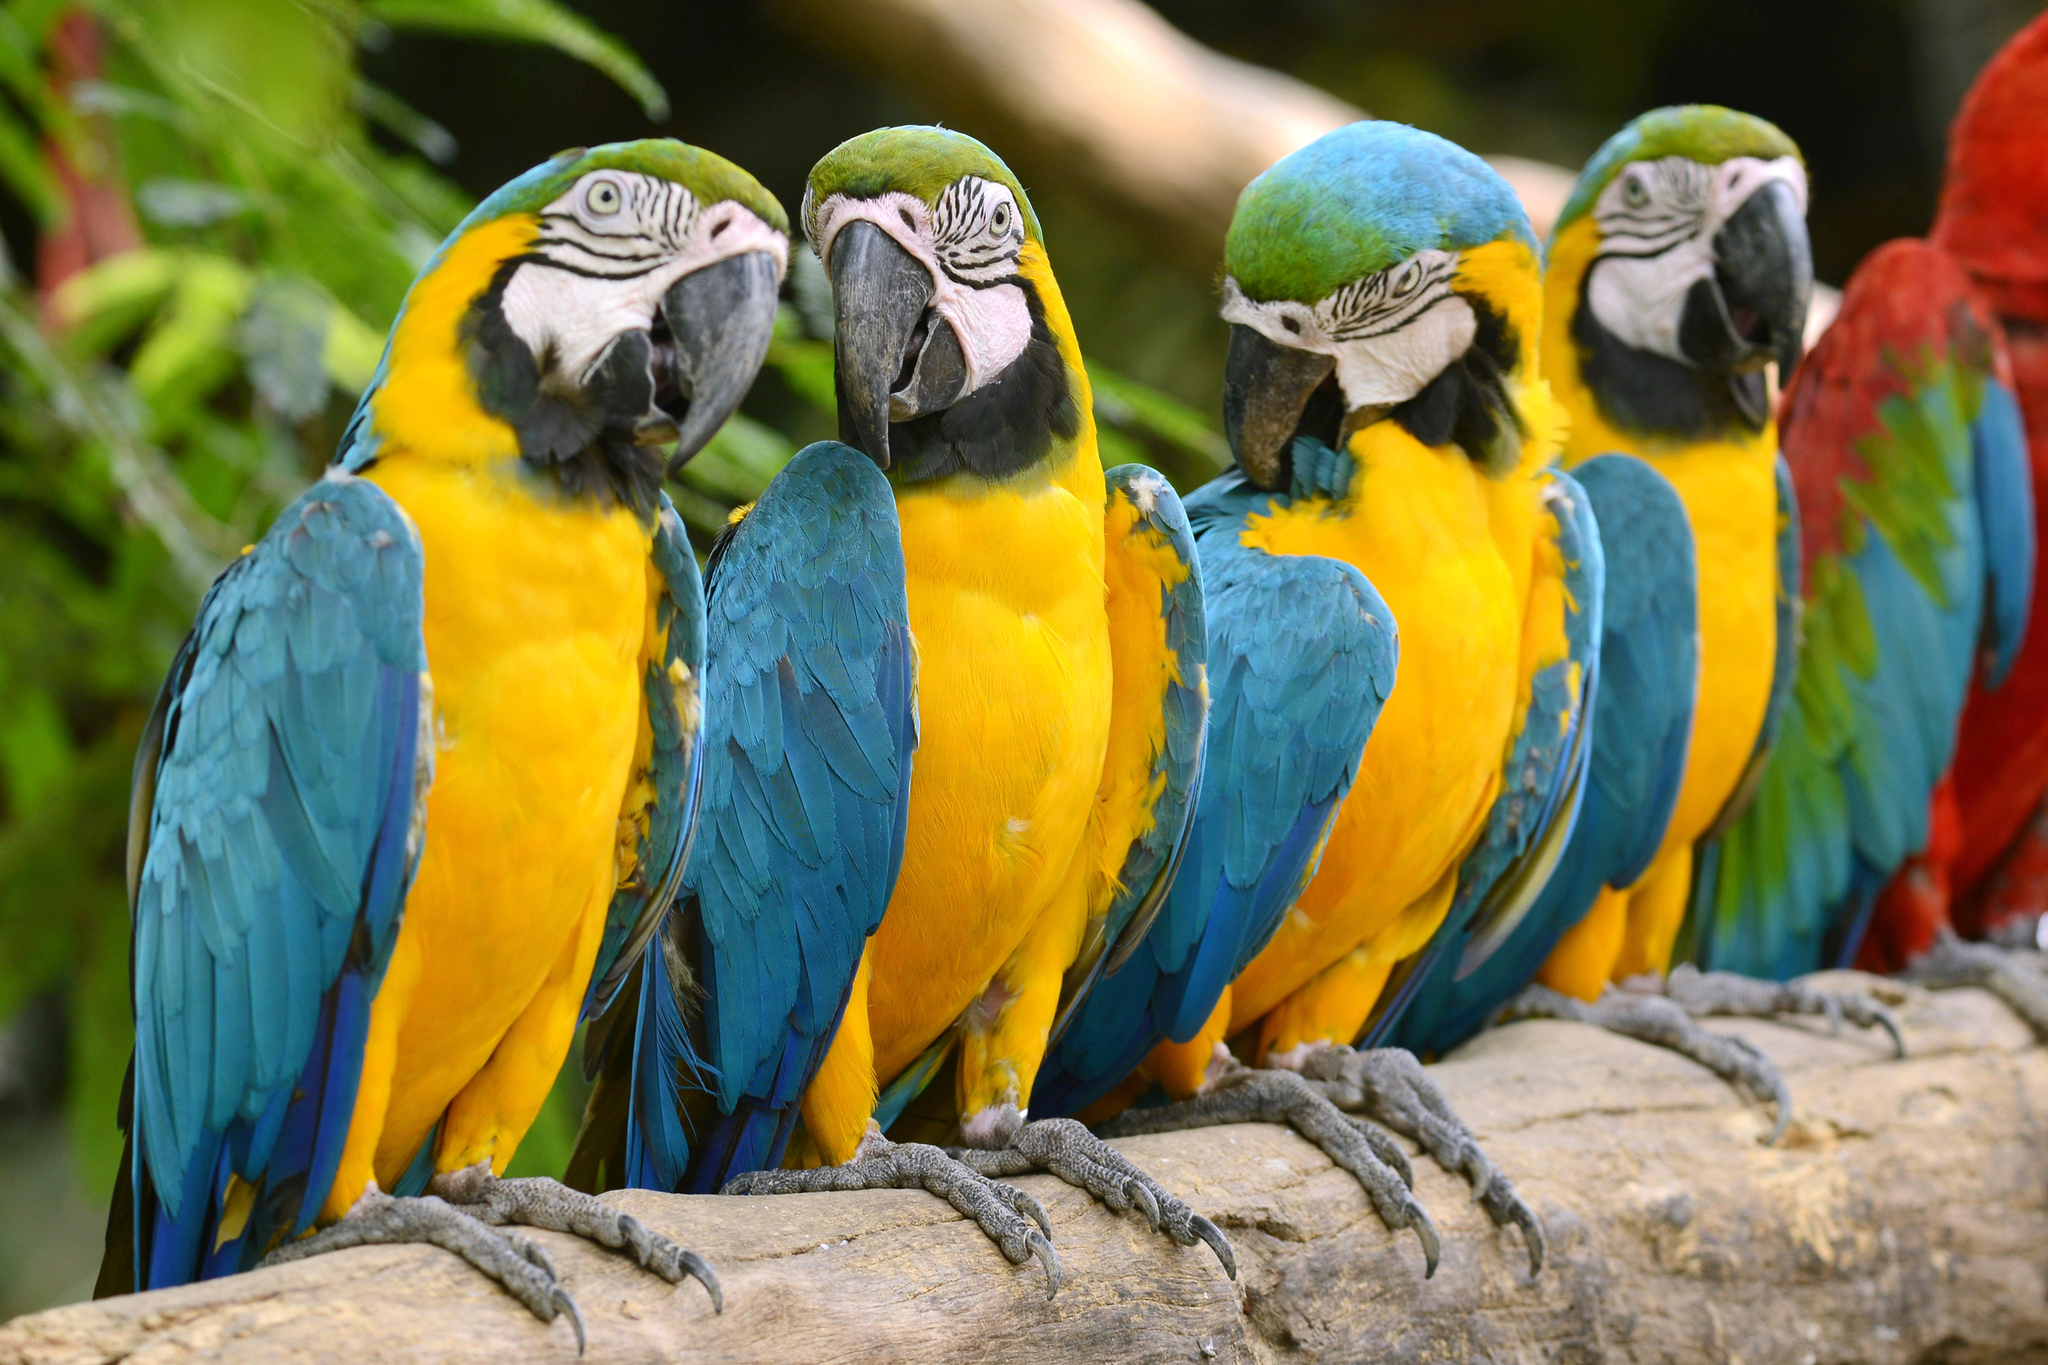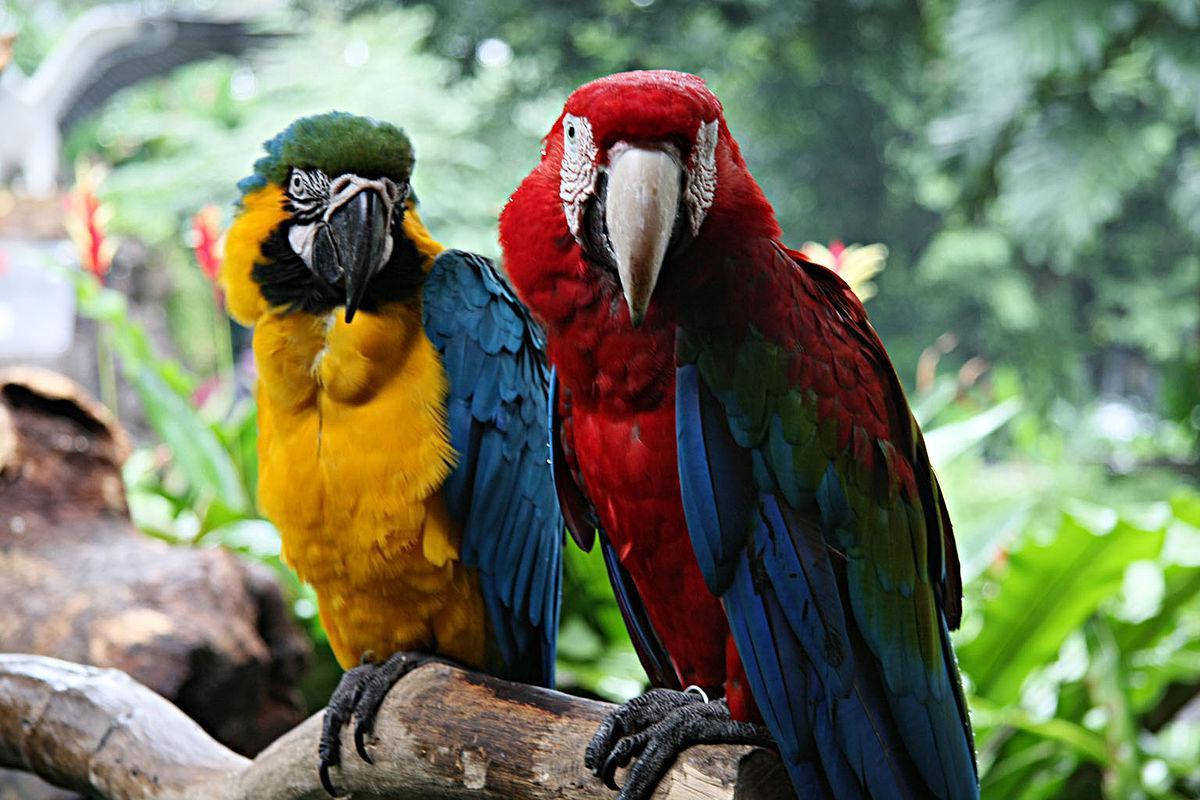The first image is the image on the left, the second image is the image on the right. Examine the images to the left and right. Is the description "The image to the right is a row of yellow fronted macaws with one red one at the left end." accurate? Answer yes or no. No. 